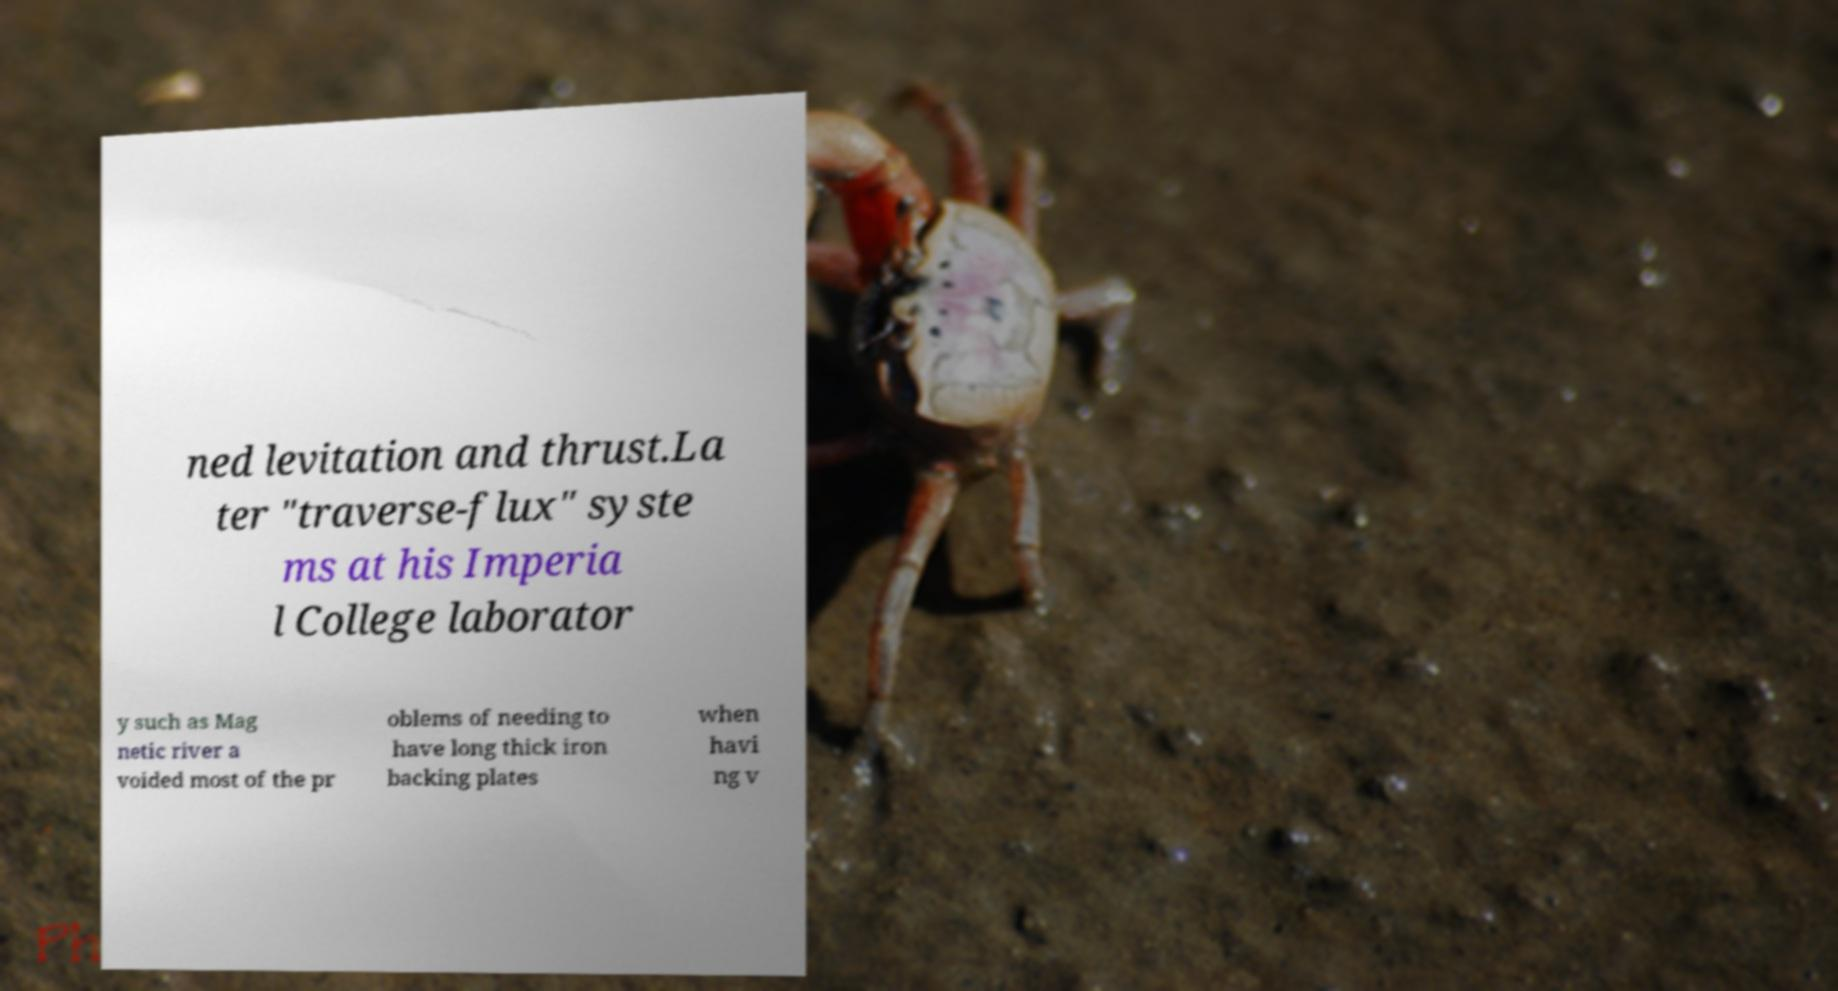There's text embedded in this image that I need extracted. Can you transcribe it verbatim? ned levitation and thrust.La ter "traverse-flux" syste ms at his Imperia l College laborator y such as Mag netic river a voided most of the pr oblems of needing to have long thick iron backing plates when havi ng v 